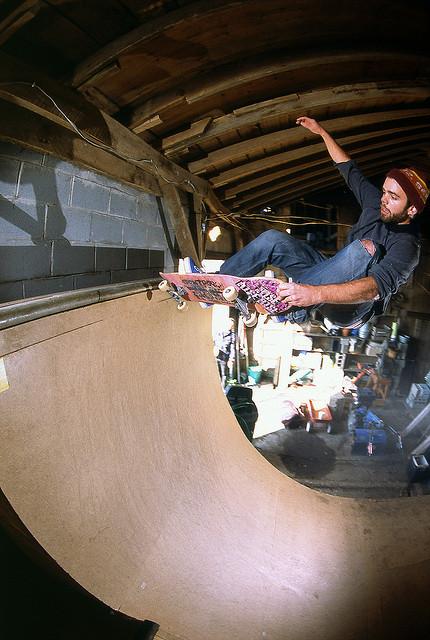What is the man's hand touching?
Short answer required. Skateboard. Is this a level surface?
Keep it brief. No. What clothing has a rip in it?
Keep it brief. Jeans. 